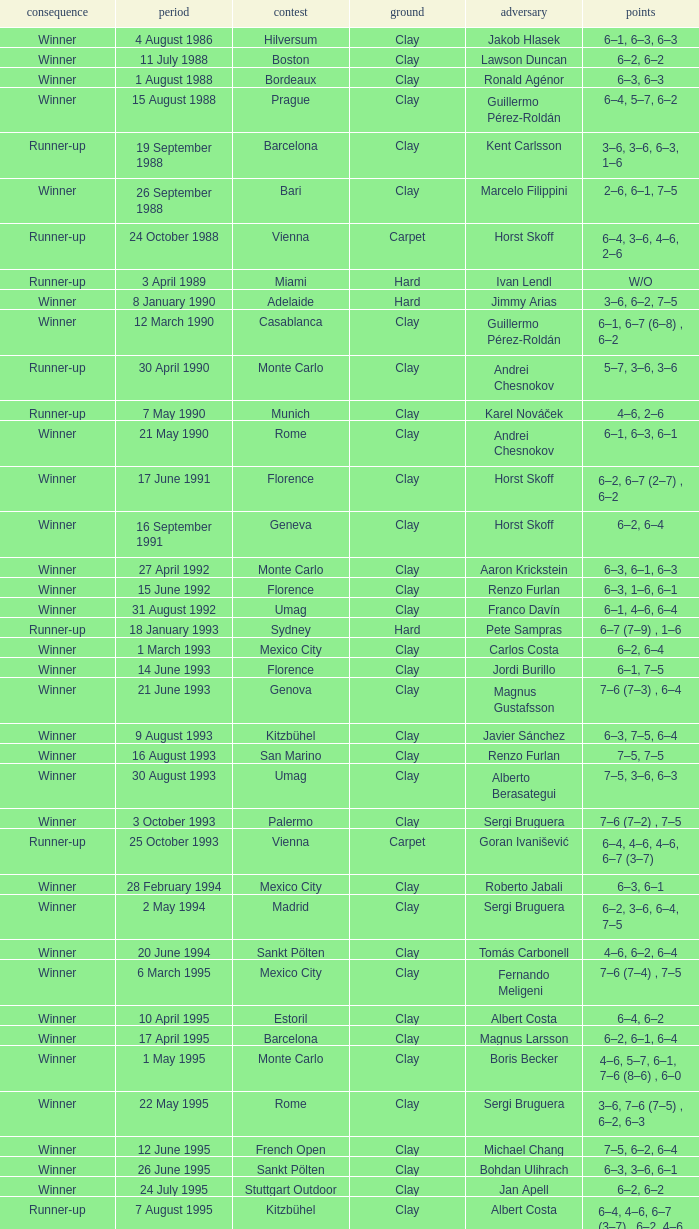What is the surface on 21 june 1993? Clay. 